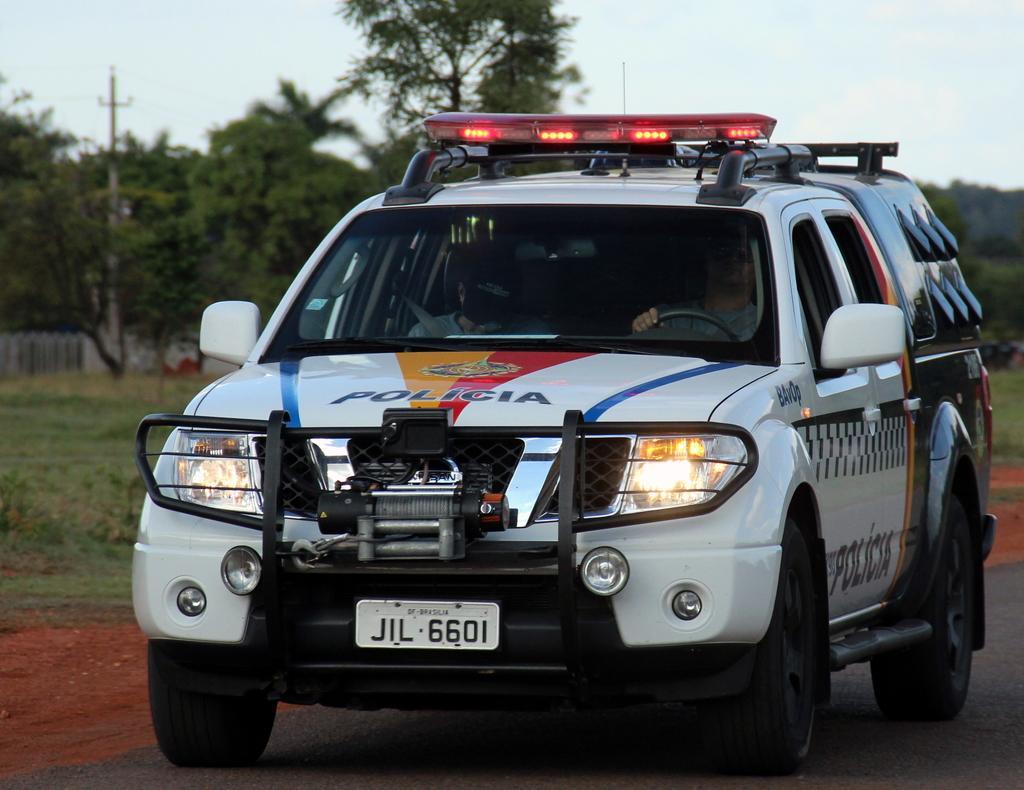Describe this image in one or two sentences. In this image, this is the police van on the road. I can see two people sitting in the van. In the background, I can see the trees and the current pole. 